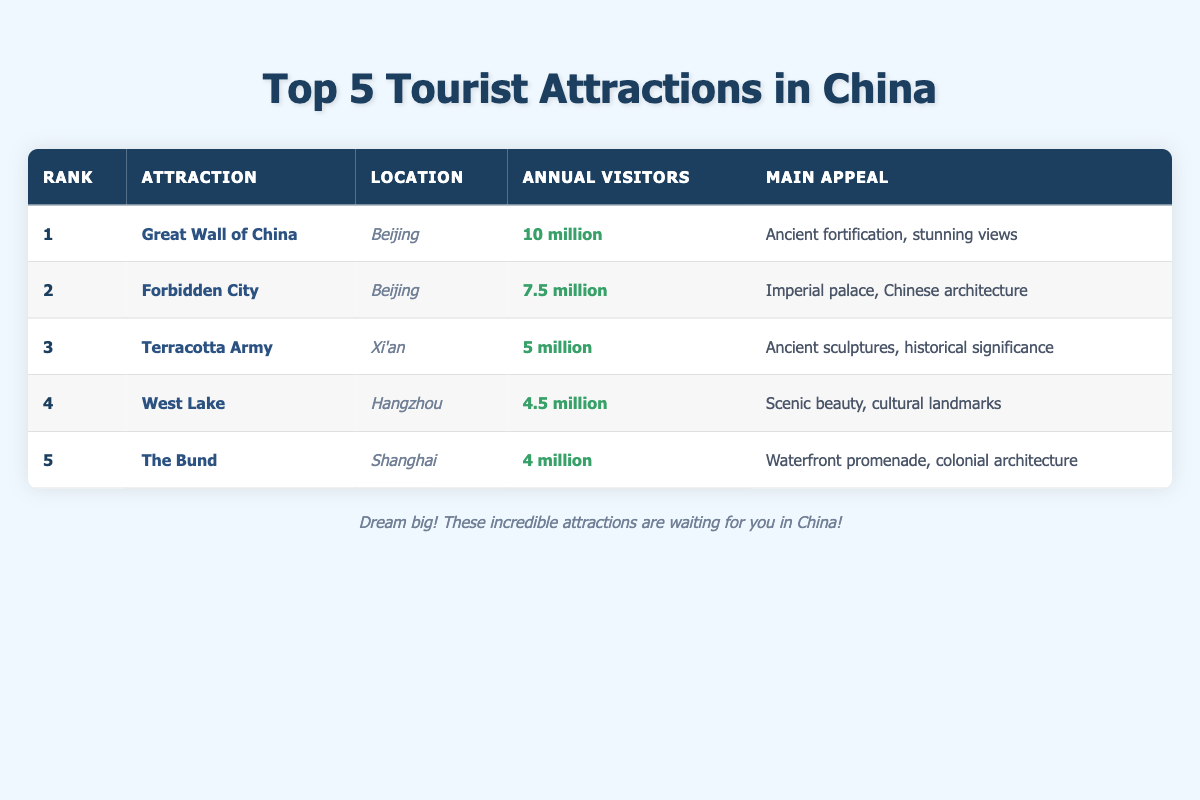What is the main appeal of the Great Wall of China? The main appeal listed for the Great Wall of China is "Ancient fortification, stunning views," which can be directly found in the table under the “Main Appeal” column for this attraction.
Answer: Ancient fortification, stunning views Which attraction has the highest annual visitors? The table shows that the Great Wall of China has the highest number of annual visitors at 10 million, making it the top-ranked attraction based on the “Annual Visitors” column.
Answer: Great Wall of China True or False: The Terracotta Army attracts more visitors than the West Lake. The table indicates that the Terracotta Army has 5 million visitors, while West Lake has 4.5 million visitors. Since 5 million is greater than 4.5 million, the statement is true.
Answer: True What is the total number of annual visitors for the top three attractions? To find the total, add the annual visitors for the top three attractions: Great Wall of China (10 million) + Forbidden City (7.5 million) + Terracotta Army (5 million). This results in a total of 22.5 million annual visitors for these three attractions.
Answer: 22.5 million Which city has the most attractions listed in the top five? By reviewing the table, Beijing has two attractions listed (Great Wall of China and Forbidden City), while the other cities (Xi'an, Hangzhou, and Shanghai) have one each. Therefore, Beijing has the most attractions in the list.
Answer: Beijing 